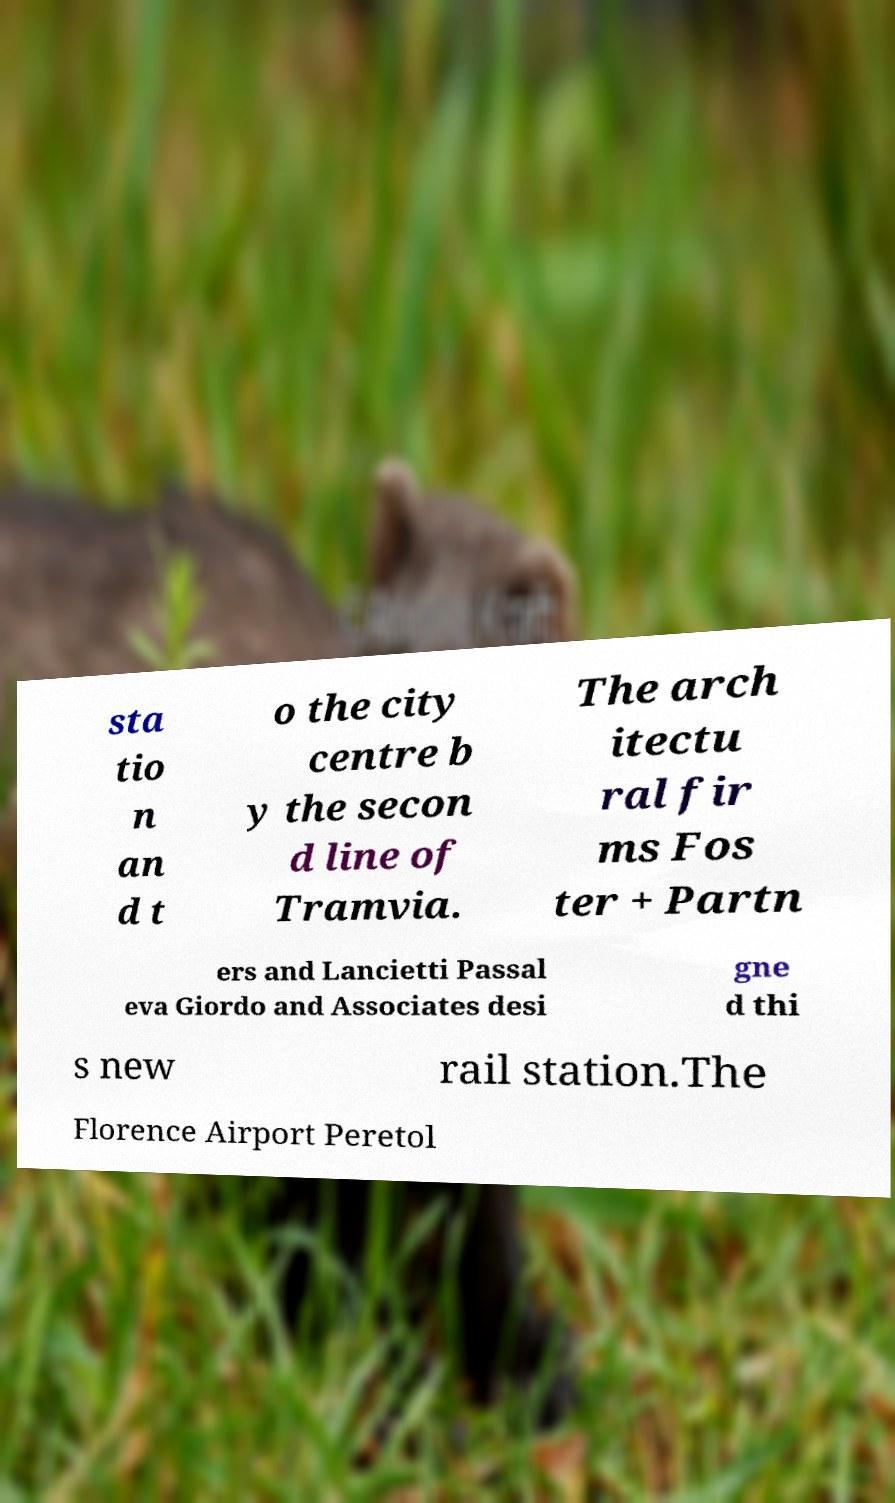Please identify and transcribe the text found in this image. sta tio n an d t o the city centre b y the secon d line of Tramvia. The arch itectu ral fir ms Fos ter + Partn ers and Lancietti Passal eva Giordo and Associates desi gne d thi s new rail station.The Florence Airport Peretol 